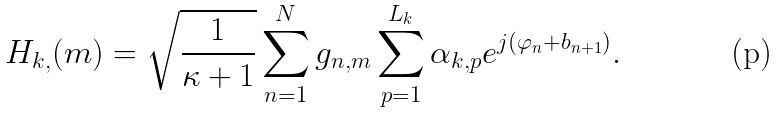Convert formula to latex. <formula><loc_0><loc_0><loc_500><loc_500>H _ { k , } ( m ) = \sqrt { \frac { 1 } { \kappa + 1 } } \sum _ { n = 1 } ^ { N } g _ { n , m } \sum _ { p = 1 } ^ { L _ { k } } \alpha _ { k , p } e ^ { j ( \varphi _ { n } + b _ { n + 1 } ) } .</formula> 